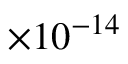Convert formula to latex. <formula><loc_0><loc_0><loc_500><loc_500>\times 1 0 ^ { - 1 4 }</formula> 